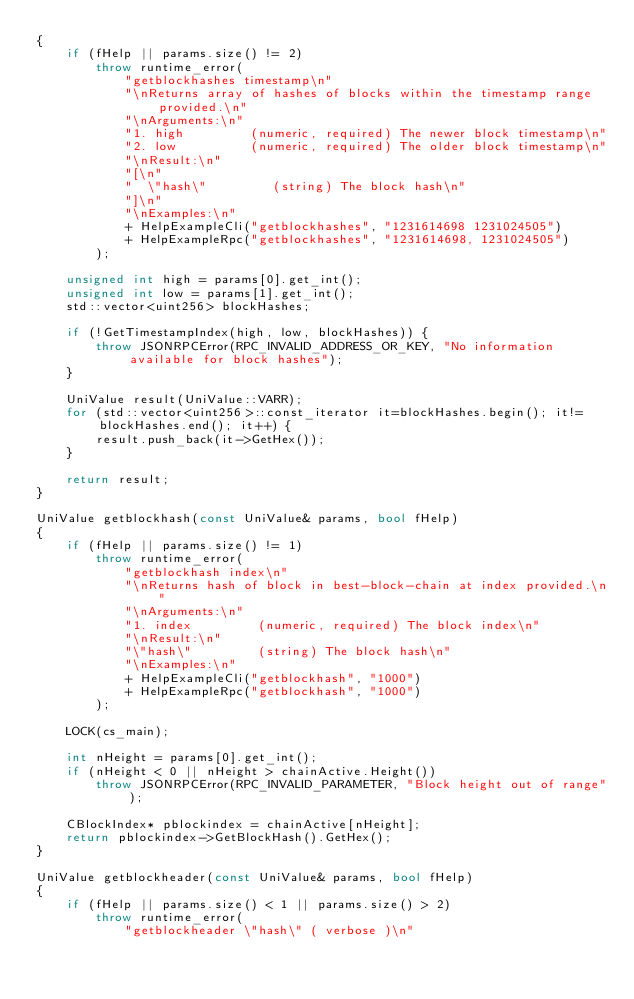<code> <loc_0><loc_0><loc_500><loc_500><_C++_>{
    if (fHelp || params.size() != 2)
        throw runtime_error(
            "getblockhashes timestamp\n"
            "\nReturns array of hashes of blocks within the timestamp range provided.\n"
            "\nArguments:\n"
            "1. high         (numeric, required) The newer block timestamp\n"
            "2. low          (numeric, required) The older block timestamp\n"
            "\nResult:\n"
            "[\n"
            "  \"hash\"         (string) The block hash\n"
            "]\n"
            "\nExamples:\n"
            + HelpExampleCli("getblockhashes", "1231614698 1231024505")
            + HelpExampleRpc("getblockhashes", "1231614698, 1231024505")
        );

    unsigned int high = params[0].get_int();
    unsigned int low = params[1].get_int();
    std::vector<uint256> blockHashes;

    if (!GetTimestampIndex(high, low, blockHashes)) {
        throw JSONRPCError(RPC_INVALID_ADDRESS_OR_KEY, "No information available for block hashes");
    }

    UniValue result(UniValue::VARR);
    for (std::vector<uint256>::const_iterator it=blockHashes.begin(); it!=blockHashes.end(); it++) {
        result.push_back(it->GetHex());
    }

    return result;
}

UniValue getblockhash(const UniValue& params, bool fHelp)
{
    if (fHelp || params.size() != 1)
        throw runtime_error(
            "getblockhash index\n"
            "\nReturns hash of block in best-block-chain at index provided.\n"
            "\nArguments:\n"
            "1. index         (numeric, required) The block index\n"
            "\nResult:\n"
            "\"hash\"         (string) The block hash\n"
            "\nExamples:\n"
            + HelpExampleCli("getblockhash", "1000")
            + HelpExampleRpc("getblockhash", "1000")
        );

    LOCK(cs_main);

    int nHeight = params[0].get_int();
    if (nHeight < 0 || nHeight > chainActive.Height())
        throw JSONRPCError(RPC_INVALID_PARAMETER, "Block height out of range");

    CBlockIndex* pblockindex = chainActive[nHeight];
    return pblockindex->GetBlockHash().GetHex();
}

UniValue getblockheader(const UniValue& params, bool fHelp)
{
    if (fHelp || params.size() < 1 || params.size() > 2)
        throw runtime_error(
            "getblockheader \"hash\" ( verbose )\n"</code> 